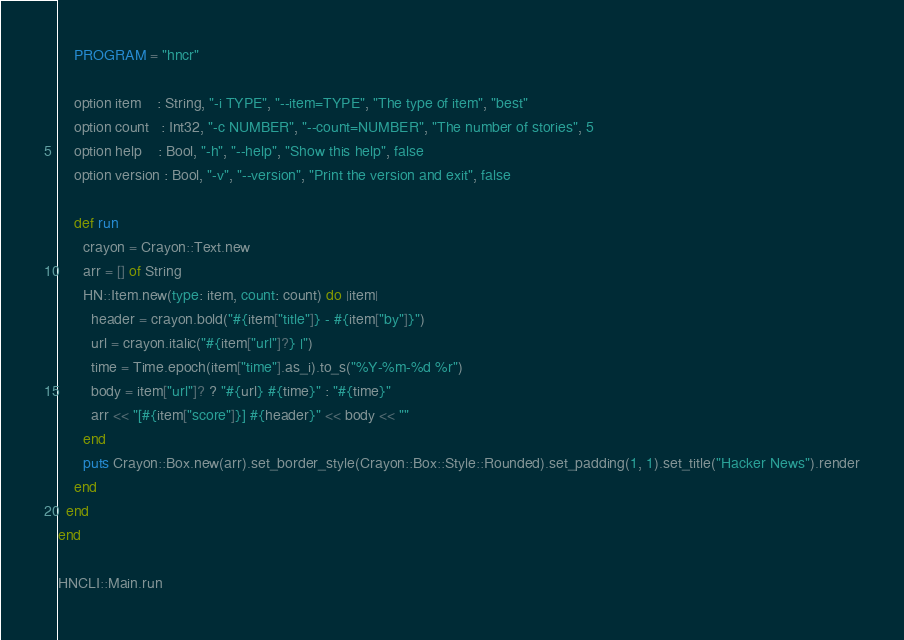Convert code to text. <code><loc_0><loc_0><loc_500><loc_500><_Crystal_>    PROGRAM = "hncr"

    option item    : String, "-i TYPE", "--item=TYPE", "The type of item", "best"
    option count   : Int32, "-c NUMBER", "--count=NUMBER", "The number of stories", 5
    option help    : Bool, "-h", "--help", "Show this help", false
    option version : Bool, "-v", "--version", "Print the version and exit", false

    def run
      crayon = Crayon::Text.new
      arr = [] of String
      HN::Item.new(type: item, count: count) do |item|
        header = crayon.bold("#{item["title"]} - #{item["by"]}")
        url = crayon.italic("#{item["url"]?} |")
        time = Time.epoch(item["time"].as_i).to_s("%Y-%m-%d %r")
        body = item["url"]? ? "#{url} #{time}" : "#{time}"
        arr << "[#{item["score"]}] #{header}" << body << ""
      end
      puts Crayon::Box.new(arr).set_border_style(Crayon::Box::Style::Rounded).set_padding(1, 1).set_title("Hacker News").render
    end
  end
end

HNCLI::Main.run
</code> 